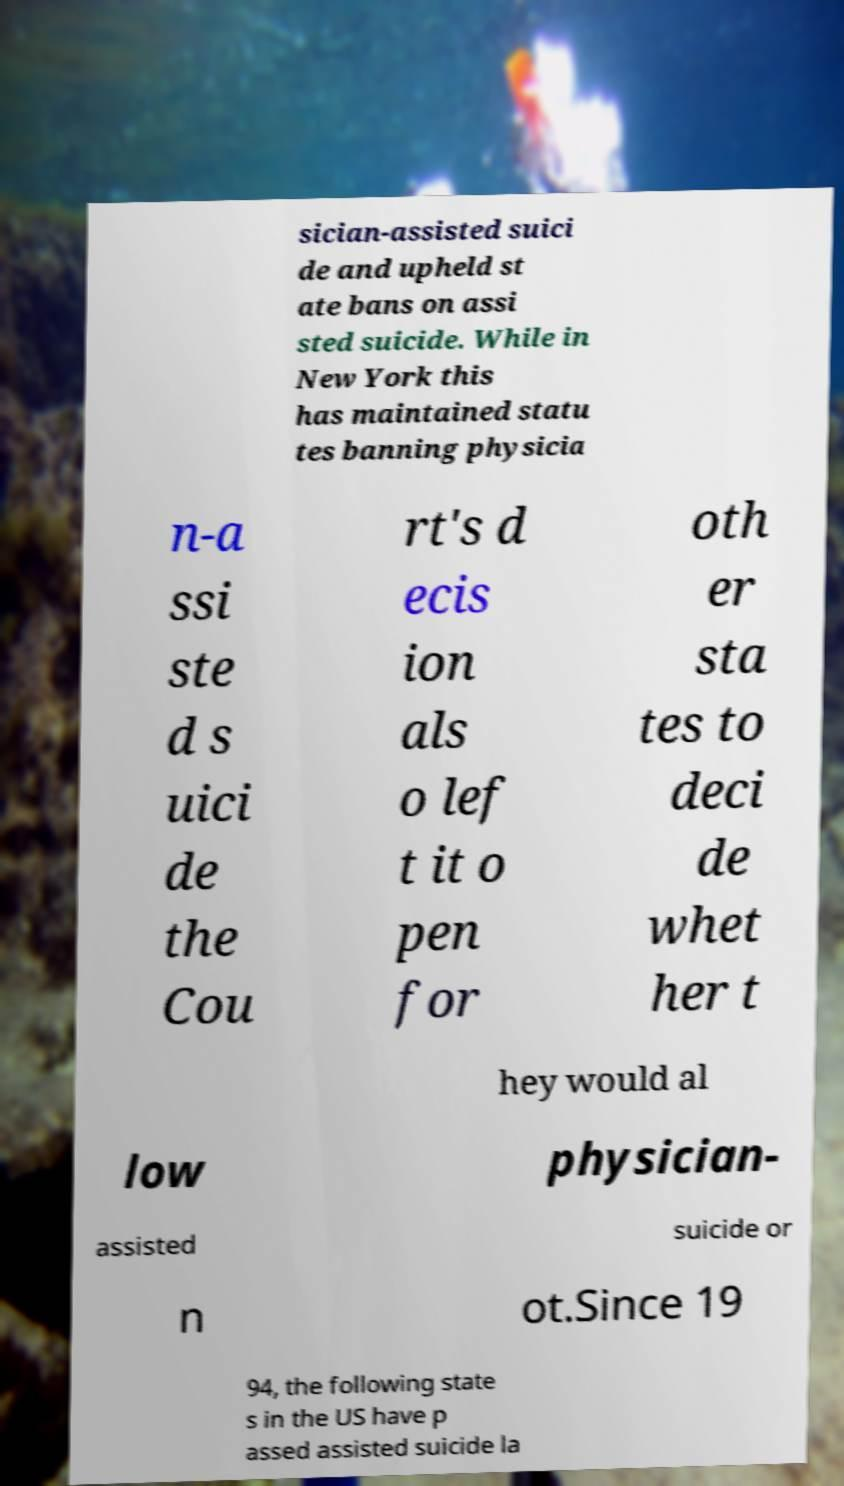What messages or text are displayed in this image? I need them in a readable, typed format. sician-assisted suici de and upheld st ate bans on assi sted suicide. While in New York this has maintained statu tes banning physicia n-a ssi ste d s uici de the Cou rt's d ecis ion als o lef t it o pen for oth er sta tes to deci de whet her t hey would al low physician- assisted suicide or n ot.Since 19 94, the following state s in the US have p assed assisted suicide la 